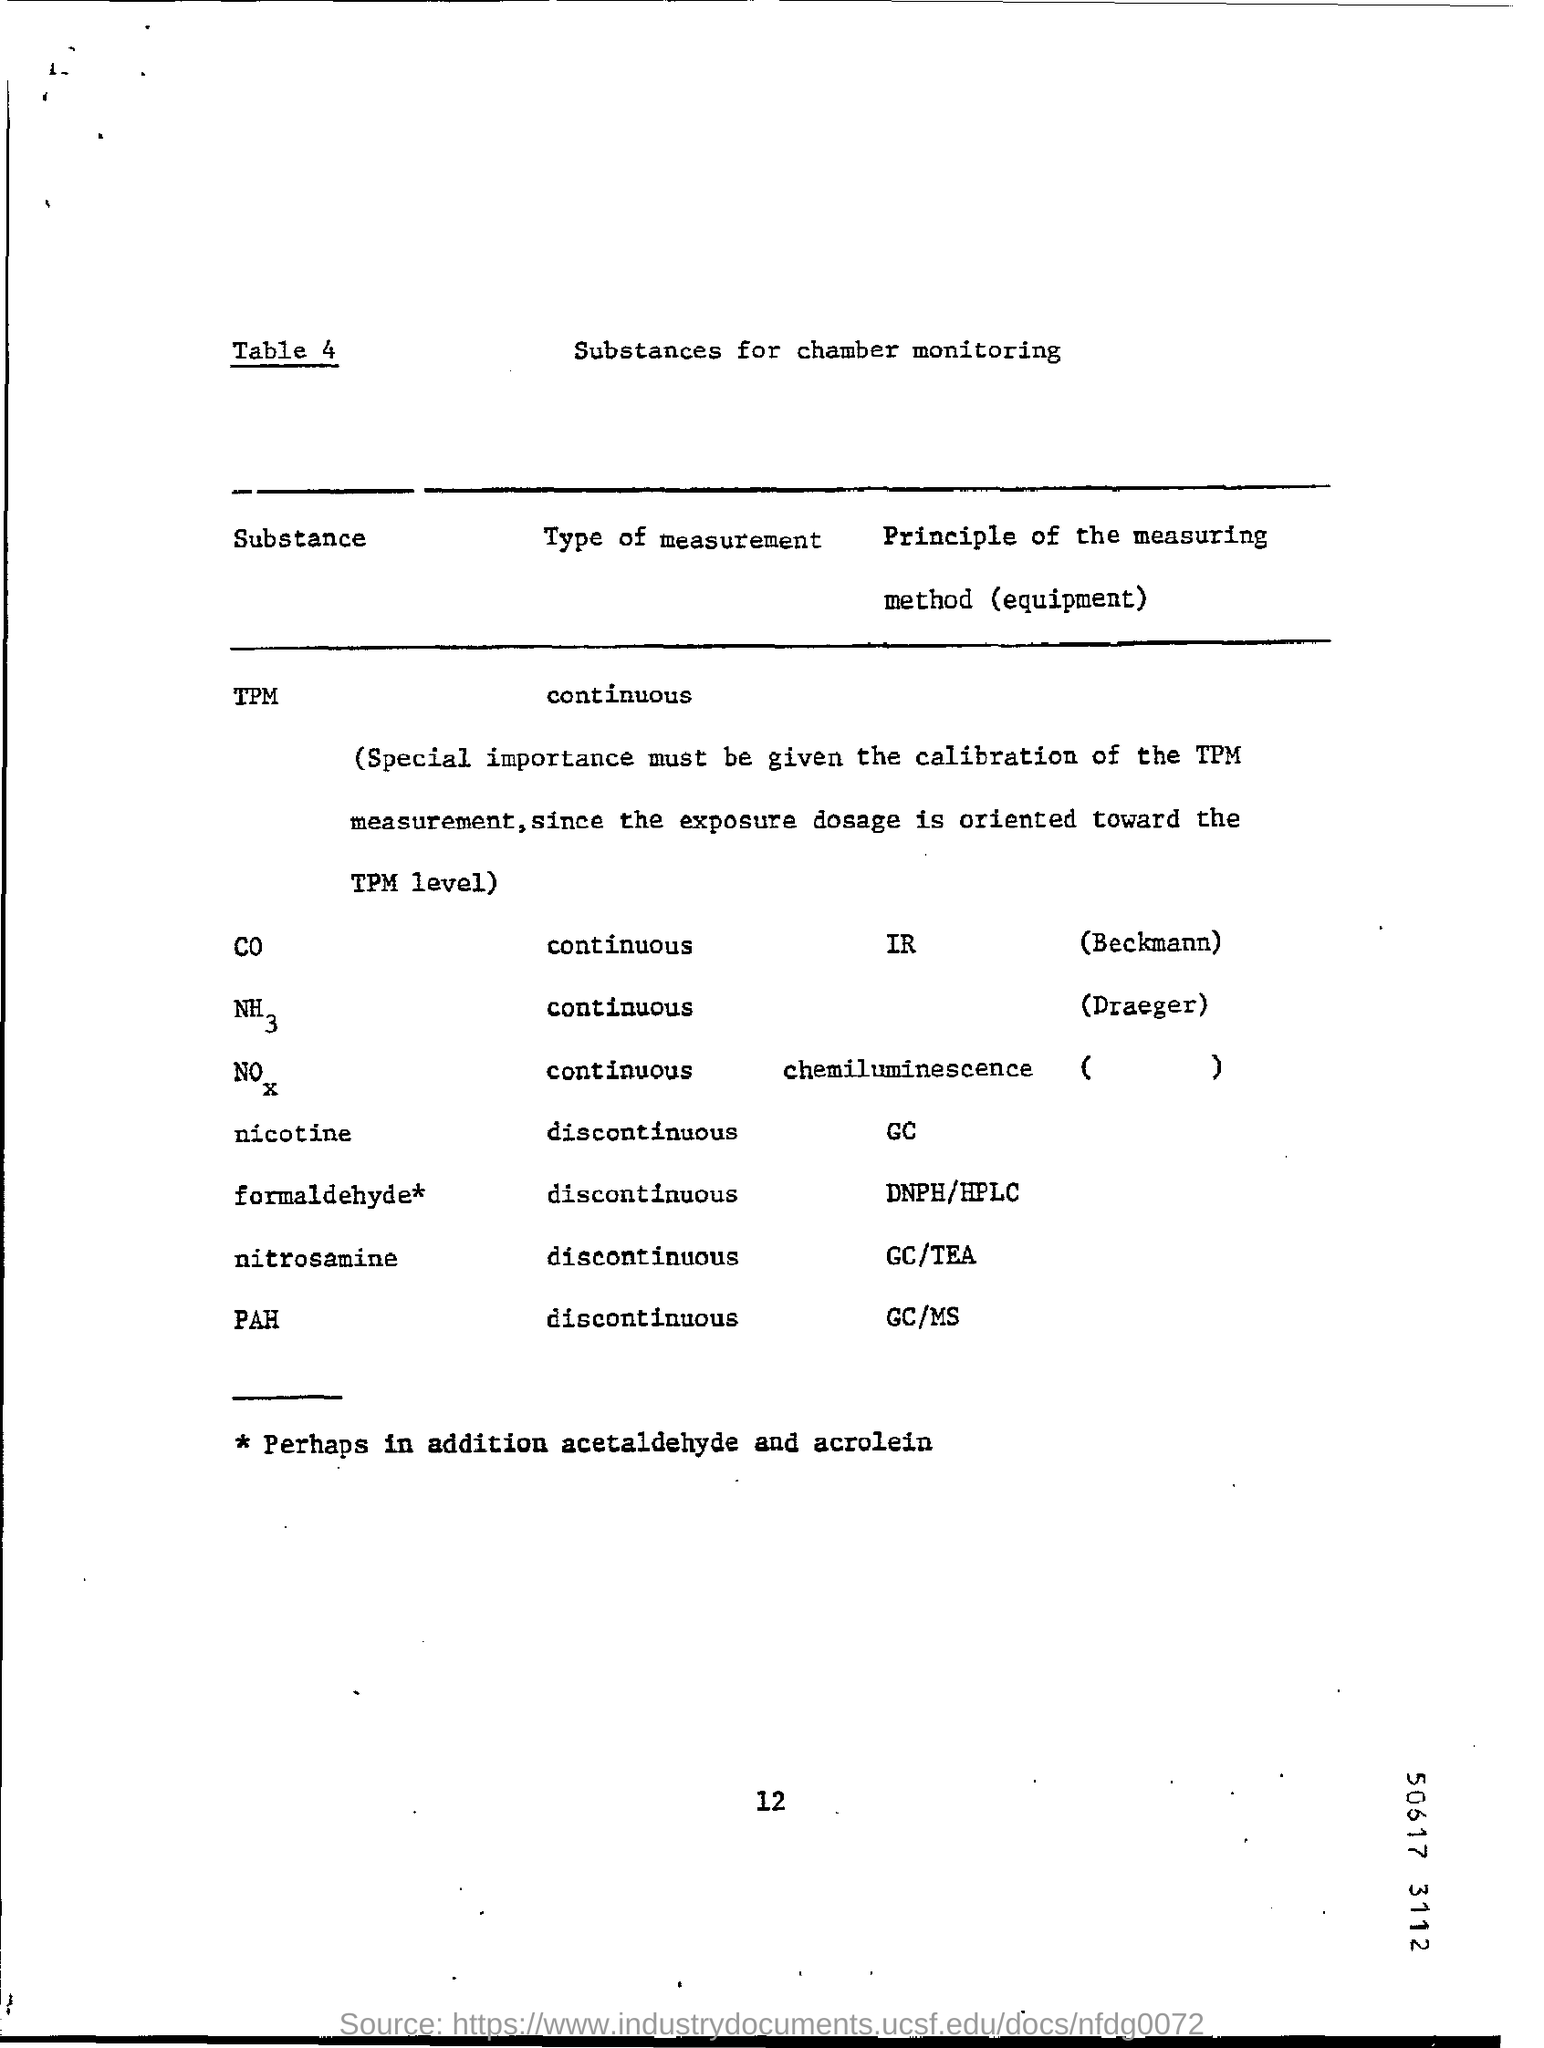Draw attention to some important aspects in this diagram. The principle of measuring method for polycyclic aromatic hydrocarbons (PAHs) is gas chromatography/mass spectrometry (GC/MS). TPM is a continuous measurement. 